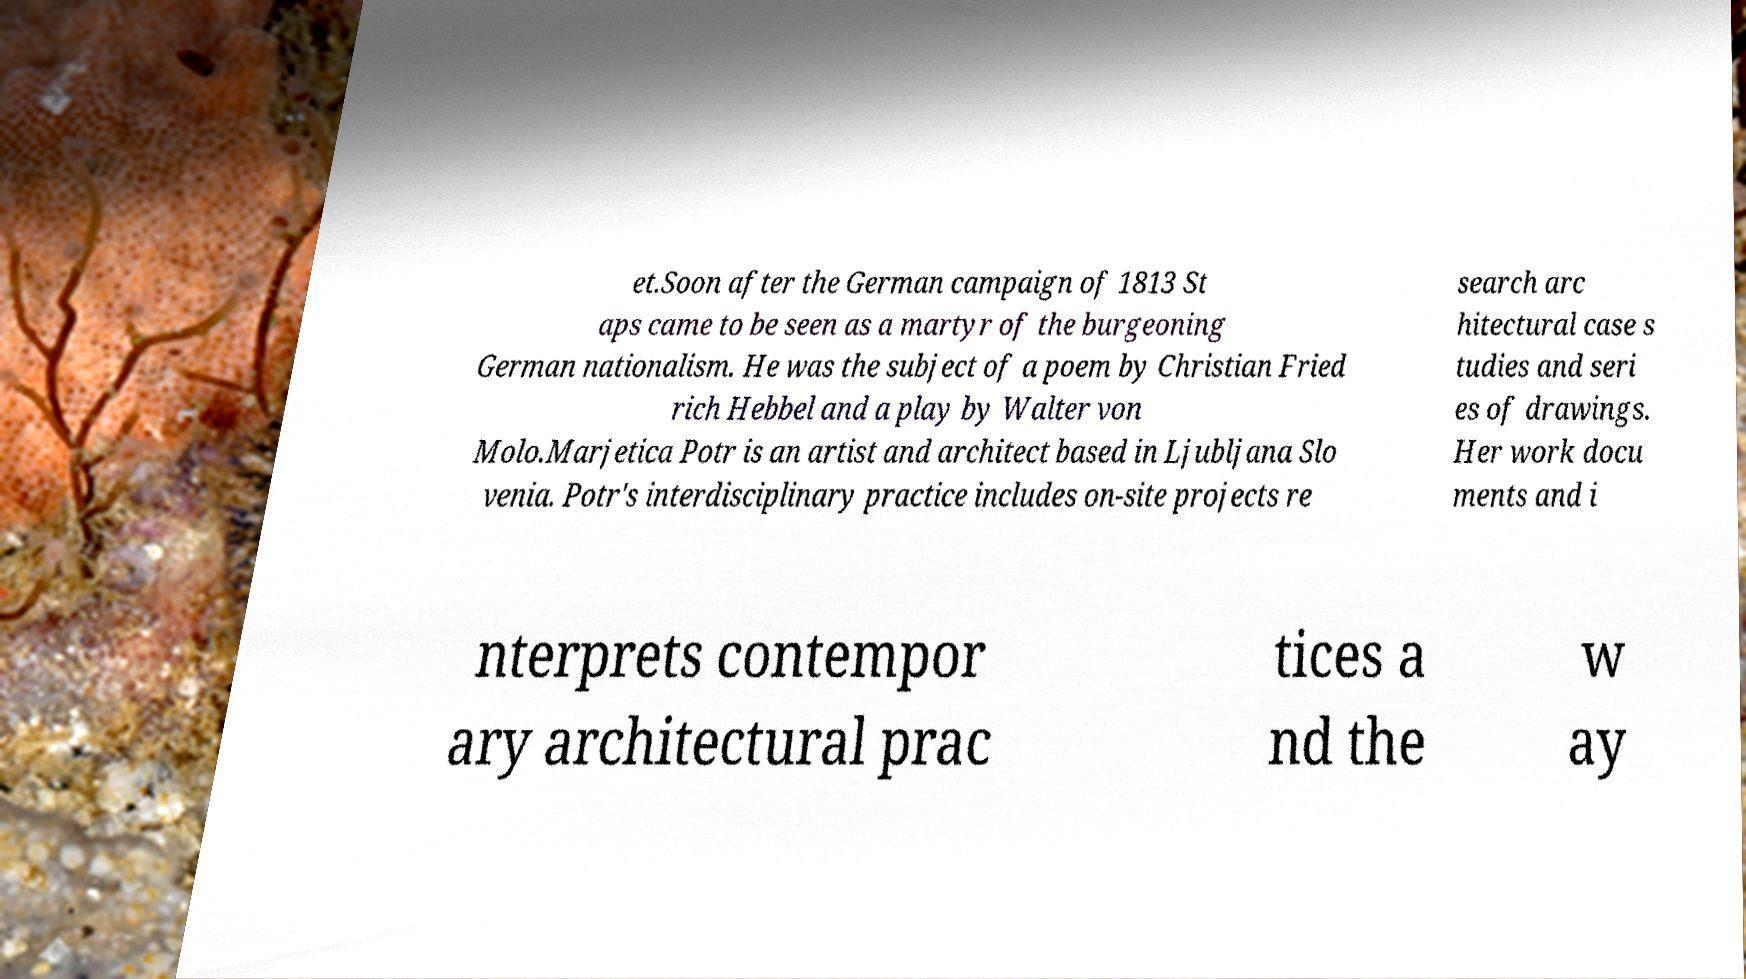There's text embedded in this image that I need extracted. Can you transcribe it verbatim? et.Soon after the German campaign of 1813 St aps came to be seen as a martyr of the burgeoning German nationalism. He was the subject of a poem by Christian Fried rich Hebbel and a play by Walter von Molo.Marjetica Potr is an artist and architect based in Ljubljana Slo venia. Potr's interdisciplinary practice includes on-site projects re search arc hitectural case s tudies and seri es of drawings. Her work docu ments and i nterprets contempor ary architectural prac tices a nd the w ay 